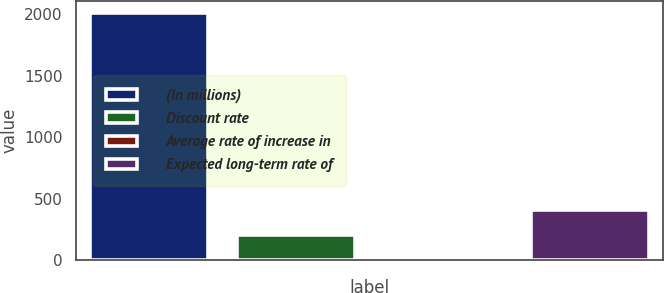<chart> <loc_0><loc_0><loc_500><loc_500><bar_chart><fcel>(In millions)<fcel>Discount rate<fcel>Average rate of increase in<fcel>Expected long-term rate of<nl><fcel>2009<fcel>204.5<fcel>4<fcel>405<nl></chart> 